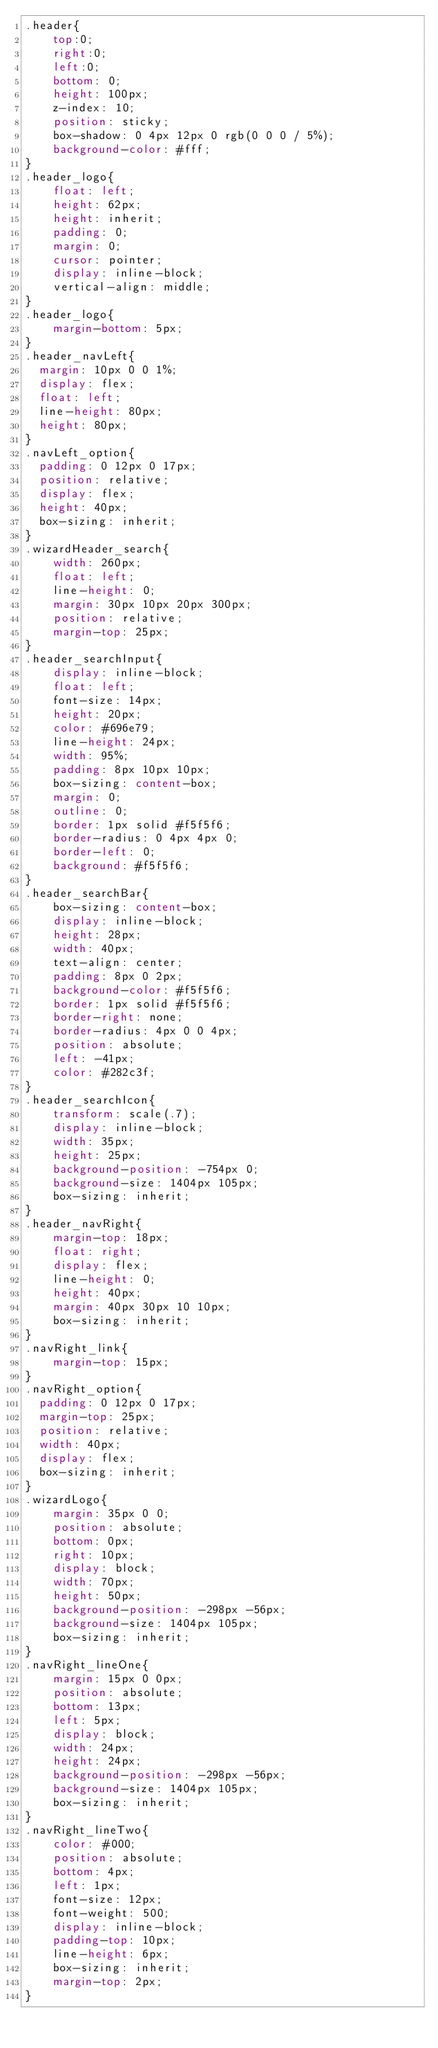Convert code to text. <code><loc_0><loc_0><loc_500><loc_500><_CSS_>.header{ 
    top:0;
    right:0;
    left:0;
    bottom: 0;
    height: 100px;
    z-index: 10; 
    position: sticky;
    box-shadow: 0 4px 12px 0 rgb(0 0 0 / 5%);
    background-color: #fff;
}
.header_logo{
    float: left;
    height: 62px;
    height: inherit;
    padding: 0;
    margin: 0;
    cursor: pointer;
    display: inline-block;
    vertical-align: middle;
}
.header_logo{
    margin-bottom: 5px;
} 
.header_navLeft{
  margin: 10px 0 0 1%;
  display: flex;
  float: left;
  line-height: 80px;
  height: 80px;  
}
.navLeft_option{
  padding: 0 12px 0 17px;
  position: relative;
  display: flex;
  height: 40px;
  box-sizing: inherit;
}
.wizardHeader_search{
    width: 260px;
    float: left;
    line-height: 0;
    margin: 30px 10px 20px 300px;
    position: relative;
    margin-top: 25px;
}
.header_searchInput{
    display: inline-block;
    float: left;
    font-size: 14px;
    height: 20px;
    color: #696e79;
    line-height: 24px;
    width: 95%;
    padding: 8px 10px 10px;
    box-sizing: content-box;
    margin: 0;
    outline: 0;
    border: 1px solid #f5f5f6;
    border-radius: 0 4px 4px 0;
    border-left: 0;
    background: #f5f5f6;
}
.header_searchBar{
    box-sizing: content-box;
    display: inline-block;
    height: 28px;
    width: 40px;
    text-align: center;
    padding: 8px 0 2px;
    background-color: #f5f5f6;
    border: 1px solid #f5f5f6;
    border-right: none;
    border-radius: 4px 0 0 4px;
    position: absolute;
    left: -41px;
    color: #282c3f;
}
.header_searchIcon{
    transform: scale(.7);
    display: inline-block;
    width: 35px;
    height: 25px;
    background-position: -754px 0;
    background-size: 1404px 105px;
    box-sizing: inherit;
}
.header_navRight{
    margin-top: 18px;
    float: right;
    display: flex;
    line-height: 0;
    height: 40px;
    margin: 40px 30px 10 10px;
    box-sizing: inherit;
}
.navRight_link{
    margin-top: 15px;
}
.navRight_option{
  padding: 0 12px 0 17px;
  margin-top: 25px;
  position: relative;
  width: 40px;
  display: flex;
  box-sizing: inherit;
}
.wizardLogo{
    margin: 35px 0 0;
    position: absolute;
    bottom: 0px;
    right: 10px;
    display: block;
    width: 70px;
    height: 50px;
    background-position: -298px -56px;
    background-size: 1404px 105px;
    box-sizing: inherit;
}
.navRight_lineOne{
    margin: 15px 0 0px;
    position: absolute;
    bottom: 13px;
    left: 5px;
    display: block;
    width: 24px;
    height: 24px;
    background-position: -298px -56px;
    background-size: 1404px 105px;
    box-sizing: inherit;
}
.navRight_lineTwo{
    color: #000;
    position: absolute;
    bottom: 4px;
    left: 1px;
    font-size: 12px;
    font-weight: 500;
    display: inline-block;
    padding-top: 10px;
    line-height: 6px;
    box-sizing: inherit;
    margin-top: 2px;
}
</code> 